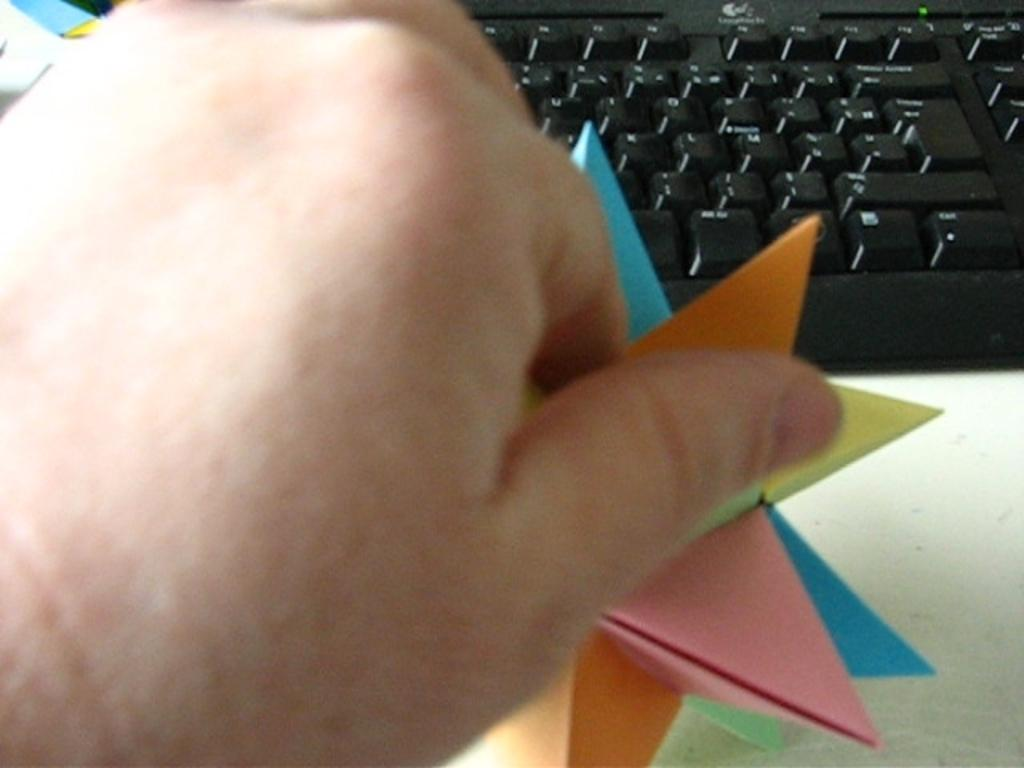What part of a person can be seen in the image? There is a person's hand in the image. What object is the person's hand interacting with? There is a keyboard in the image. What is the person holding in their hand? There is a paper in the person's hand. What type of peace symbol can be seen on the keyboard in the image? There is no peace symbol present on the keyboard in the image. 